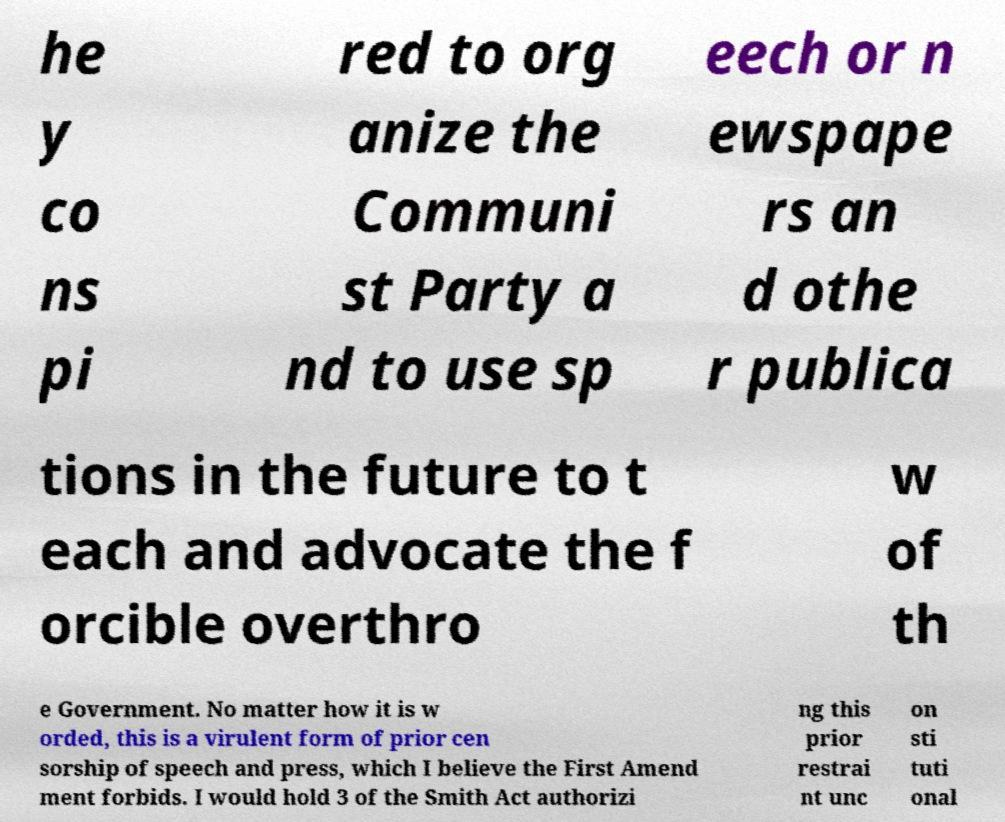Can you read and provide the text displayed in the image?This photo seems to have some interesting text. Can you extract and type it out for me? he y co ns pi red to org anize the Communi st Party a nd to use sp eech or n ewspape rs an d othe r publica tions in the future to t each and advocate the f orcible overthro w of th e Government. No matter how it is w orded, this is a virulent form of prior cen sorship of speech and press, which I believe the First Amend ment forbids. I would hold 3 of the Smith Act authorizi ng this prior restrai nt unc on sti tuti onal 